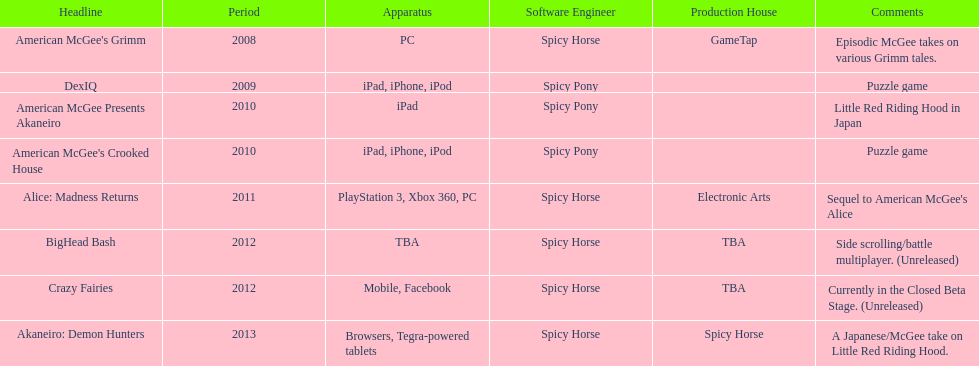How many games did spicy horse develop in total? 5. 